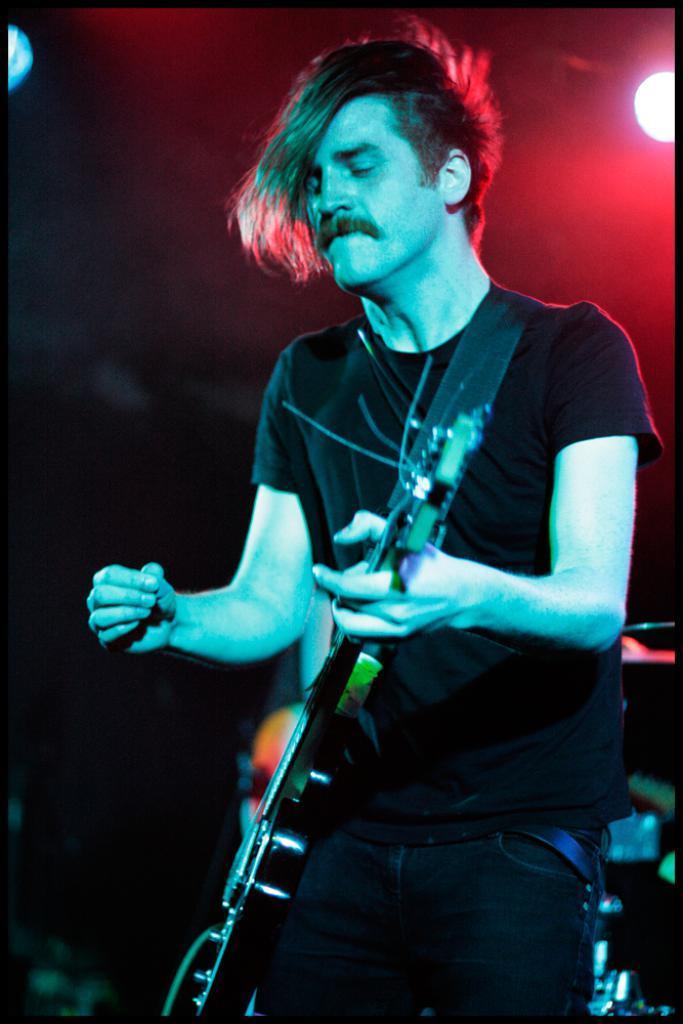Please provide a concise description of this image. In this Image I see a man who is standing and holding a guitar. In the background I see the light. 